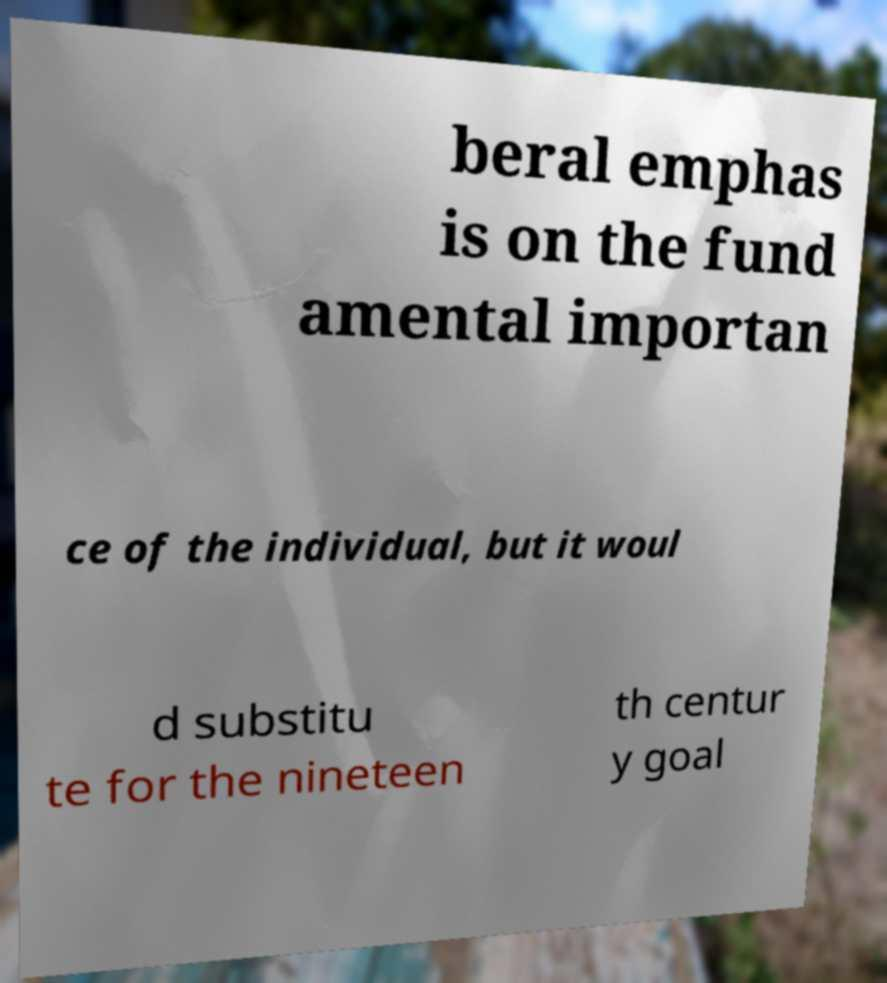What messages or text are displayed in this image? I need them in a readable, typed format. beral emphas is on the fund amental importan ce of the individual, but it woul d substitu te for the nineteen th centur y goal 